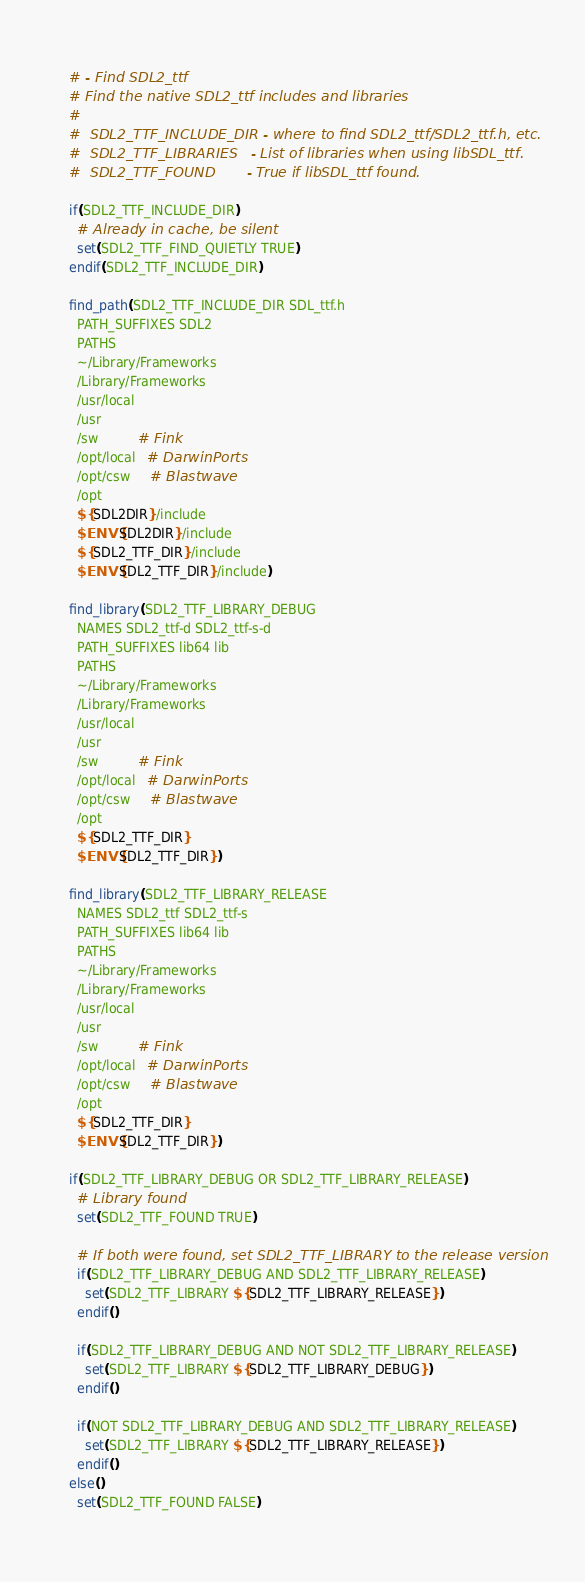<code> <loc_0><loc_0><loc_500><loc_500><_CMake_># - Find SDL2_ttf
# Find the native SDL2_ttf includes and libraries
#
#  SDL2_TTF_INCLUDE_DIR - where to find SDL2_ttf/SDL2_ttf.h, etc.
#  SDL2_TTF_LIBRARIES   - List of libraries when using libSDL_ttf.
#  SDL2_TTF_FOUND       - True if libSDL_ttf found.

if(SDL2_TTF_INCLUDE_DIR)
  # Already in cache, be silent
  set(SDL2_TTF_FIND_QUIETLY TRUE)
endif(SDL2_TTF_INCLUDE_DIR)

find_path(SDL2_TTF_INCLUDE_DIR SDL_ttf.h
  PATH_SUFFIXES SDL2
  PATHS
  ~/Library/Frameworks
  /Library/Frameworks
  /usr/local
  /usr
  /sw          # Fink
  /opt/local   # DarwinPorts
  /opt/csw     # Blastwave
  /opt
  ${SDL2DIR}/include
  $ENV{SDL2DIR}/include
  ${SDL2_TTF_DIR}/include
  $ENV{SDL2_TTF_DIR}/include)

find_library(SDL2_TTF_LIBRARY_DEBUG
  NAMES SDL2_ttf-d SDL2_ttf-s-d
  PATH_SUFFIXES lib64 lib
  PATHS
  ~/Library/Frameworks
  /Library/Frameworks
  /usr/local
  /usr
  /sw          # Fink
  /opt/local   # DarwinPorts
  /opt/csw     # Blastwave
  /opt
  ${SDL2_TTF_DIR}
  $ENV{SDL2_TTF_DIR})

find_library(SDL2_TTF_LIBRARY_RELEASE
  NAMES SDL2_ttf SDL2_ttf-s
  PATH_SUFFIXES lib64 lib
  PATHS
  ~/Library/Frameworks
  /Library/Frameworks
  /usr/local
  /usr
  /sw          # Fink
  /opt/local   # DarwinPorts
  /opt/csw     # Blastwave
  /opt
  ${SDL2_TTF_DIR}
  $ENV{SDL2_TTF_DIR})

if(SDL2_TTF_LIBRARY_DEBUG OR SDL2_TTF_LIBRARY_RELEASE)
  # Library found
  set(SDL2_TTF_FOUND TRUE)

  # If both were found, set SDL2_TTF_LIBRARY to the release version
  if(SDL2_TTF_LIBRARY_DEBUG AND SDL2_TTF_LIBRARY_RELEASE)
    set(SDL2_TTF_LIBRARY ${SDL2_TTF_LIBRARY_RELEASE})
  endif()

  if(SDL2_TTF_LIBRARY_DEBUG AND NOT SDL2_TTF_LIBRARY_RELEASE)
    set(SDL2_TTF_LIBRARY ${SDL2_TTF_LIBRARY_DEBUG})
  endif()

  if(NOT SDL2_TTF_LIBRARY_DEBUG AND SDL2_TTF_LIBRARY_RELEASE)
    set(SDL2_TTF_LIBRARY ${SDL2_TTF_LIBRARY_RELEASE})
  endif()
else()
  set(SDL2_TTF_FOUND FALSE)</code> 